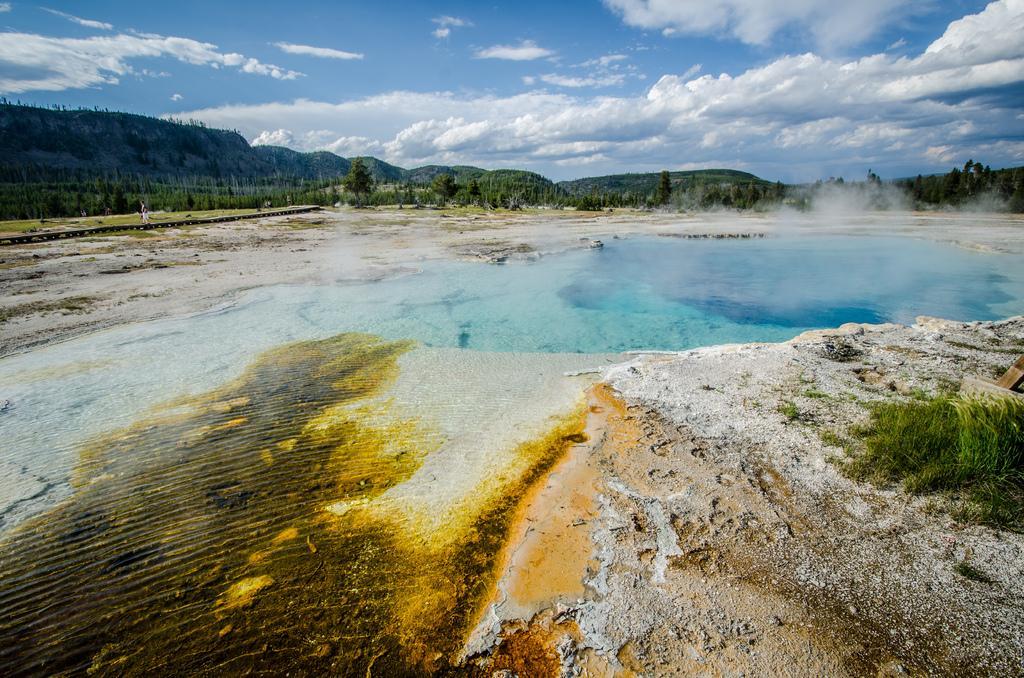In one or two sentences, can you explain what this image depicts? In this picture I can see grass, water, trees, there are hills, and in the background there is sky. 